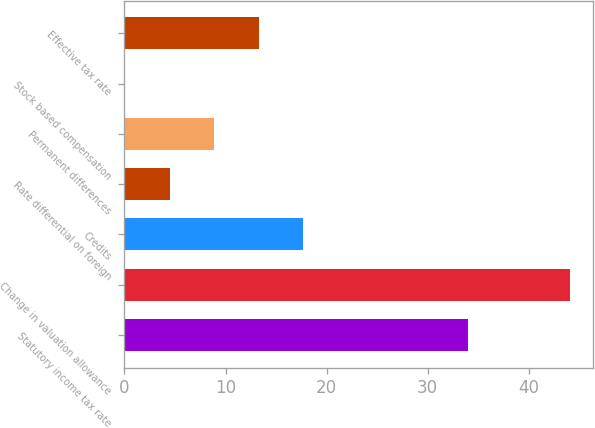Convert chart to OTSL. <chart><loc_0><loc_0><loc_500><loc_500><bar_chart><fcel>Statutory income tax rate<fcel>Change in valuation allowance<fcel>Credits<fcel>Rate differential on foreign<fcel>Permanent differences<fcel>Stock based compensation<fcel>Effective tax rate<nl><fcel>34<fcel>44.1<fcel>17.7<fcel>4.5<fcel>8.9<fcel>0.1<fcel>13.3<nl></chart> 